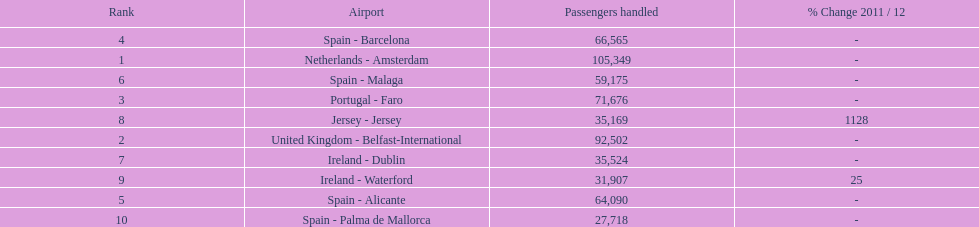Which airport has no more than 30,000 passengers handled among the 10 busiest routes to and from london southend airport in 2012? Spain - Palma de Mallorca. 